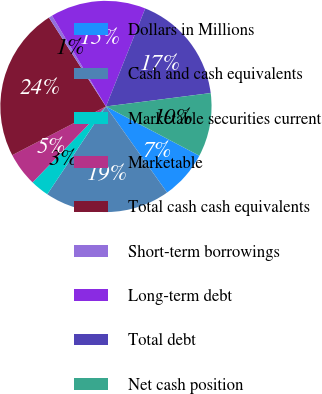Convert chart. <chart><loc_0><loc_0><loc_500><loc_500><pie_chart><fcel>Dollars in Millions<fcel>Cash and cash equivalents<fcel>Marketable securitiescurrent<fcel>Marketable<fcel>Total cash cash equivalents<fcel>Short-term borrowings<fcel>Long-term debt<fcel>Total debt<fcel>Net cash position<nl><fcel>7.45%<fcel>19.2%<fcel>2.85%<fcel>5.15%<fcel>23.54%<fcel>0.55%<fcel>14.6%<fcel>16.9%<fcel>9.75%<nl></chart> 